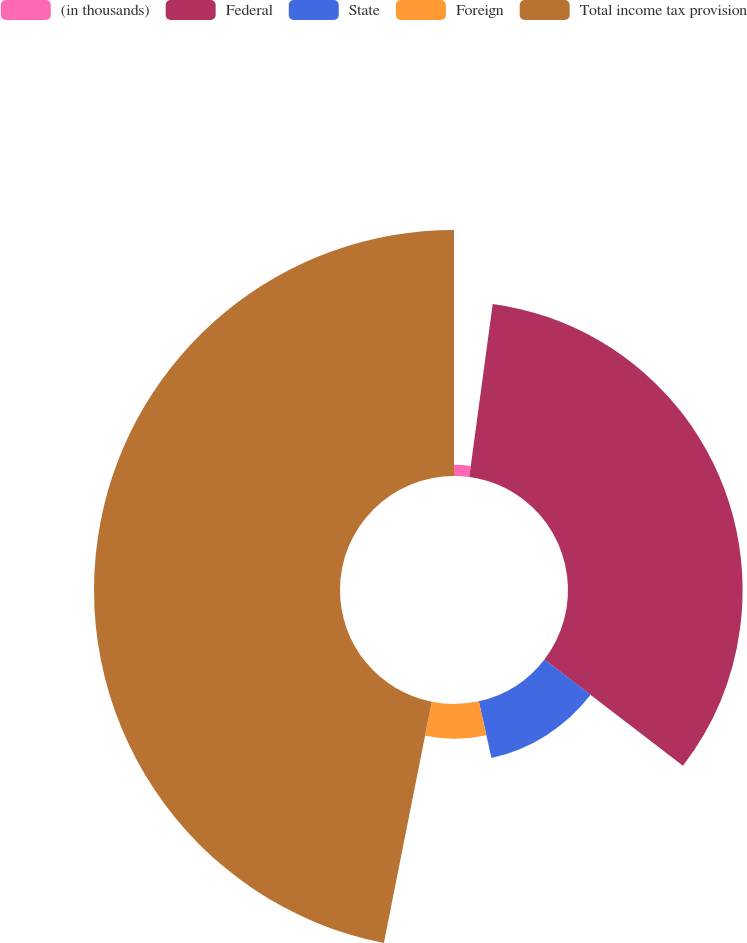Convert chart. <chart><loc_0><loc_0><loc_500><loc_500><pie_chart><fcel>(in thousands)<fcel>Federal<fcel>State<fcel>Foreign<fcel>Total income tax provision<nl><fcel>2.14%<fcel>33.28%<fcel>11.09%<fcel>6.61%<fcel>46.88%<nl></chart> 